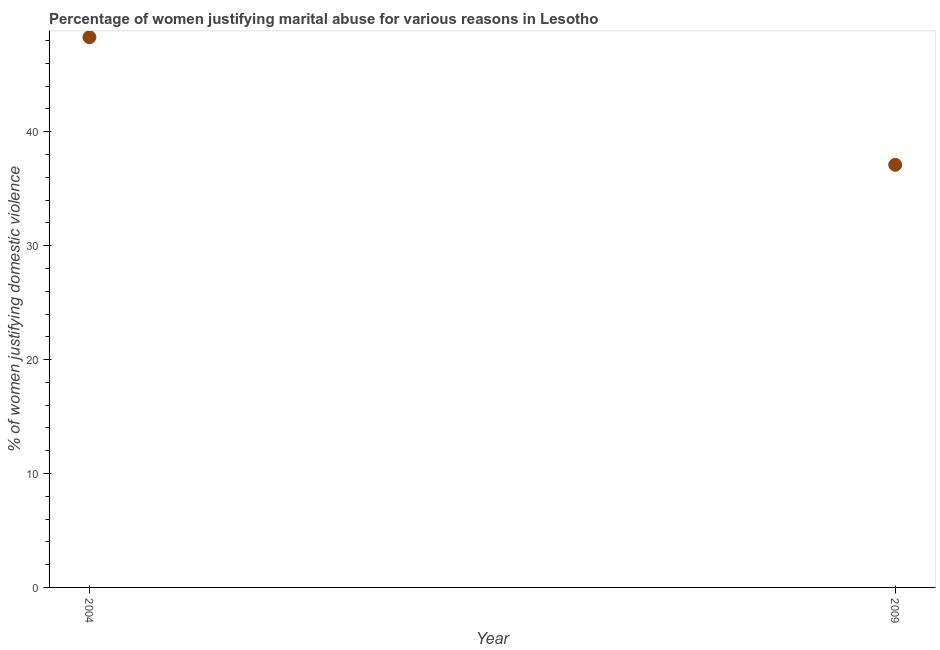What is the percentage of women justifying marital abuse in 2009?
Your answer should be compact. 37.1. Across all years, what is the maximum percentage of women justifying marital abuse?
Your answer should be very brief. 48.3. Across all years, what is the minimum percentage of women justifying marital abuse?
Provide a short and direct response. 37.1. In which year was the percentage of women justifying marital abuse maximum?
Offer a terse response. 2004. What is the sum of the percentage of women justifying marital abuse?
Your answer should be compact. 85.4. What is the difference between the percentage of women justifying marital abuse in 2004 and 2009?
Your response must be concise. 11.2. What is the average percentage of women justifying marital abuse per year?
Give a very brief answer. 42.7. What is the median percentage of women justifying marital abuse?
Provide a succinct answer. 42.7. What is the ratio of the percentage of women justifying marital abuse in 2004 to that in 2009?
Make the answer very short. 1.3. Is the percentage of women justifying marital abuse in 2004 less than that in 2009?
Make the answer very short. No. Does the percentage of women justifying marital abuse monotonically increase over the years?
Provide a succinct answer. No. How many years are there in the graph?
Your answer should be compact. 2. What is the difference between two consecutive major ticks on the Y-axis?
Provide a short and direct response. 10. Does the graph contain any zero values?
Keep it short and to the point. No. What is the title of the graph?
Your answer should be very brief. Percentage of women justifying marital abuse for various reasons in Lesotho. What is the label or title of the X-axis?
Provide a short and direct response. Year. What is the label or title of the Y-axis?
Ensure brevity in your answer.  % of women justifying domestic violence. What is the % of women justifying domestic violence in 2004?
Ensure brevity in your answer.  48.3. What is the % of women justifying domestic violence in 2009?
Your response must be concise. 37.1. What is the ratio of the % of women justifying domestic violence in 2004 to that in 2009?
Ensure brevity in your answer.  1.3. 